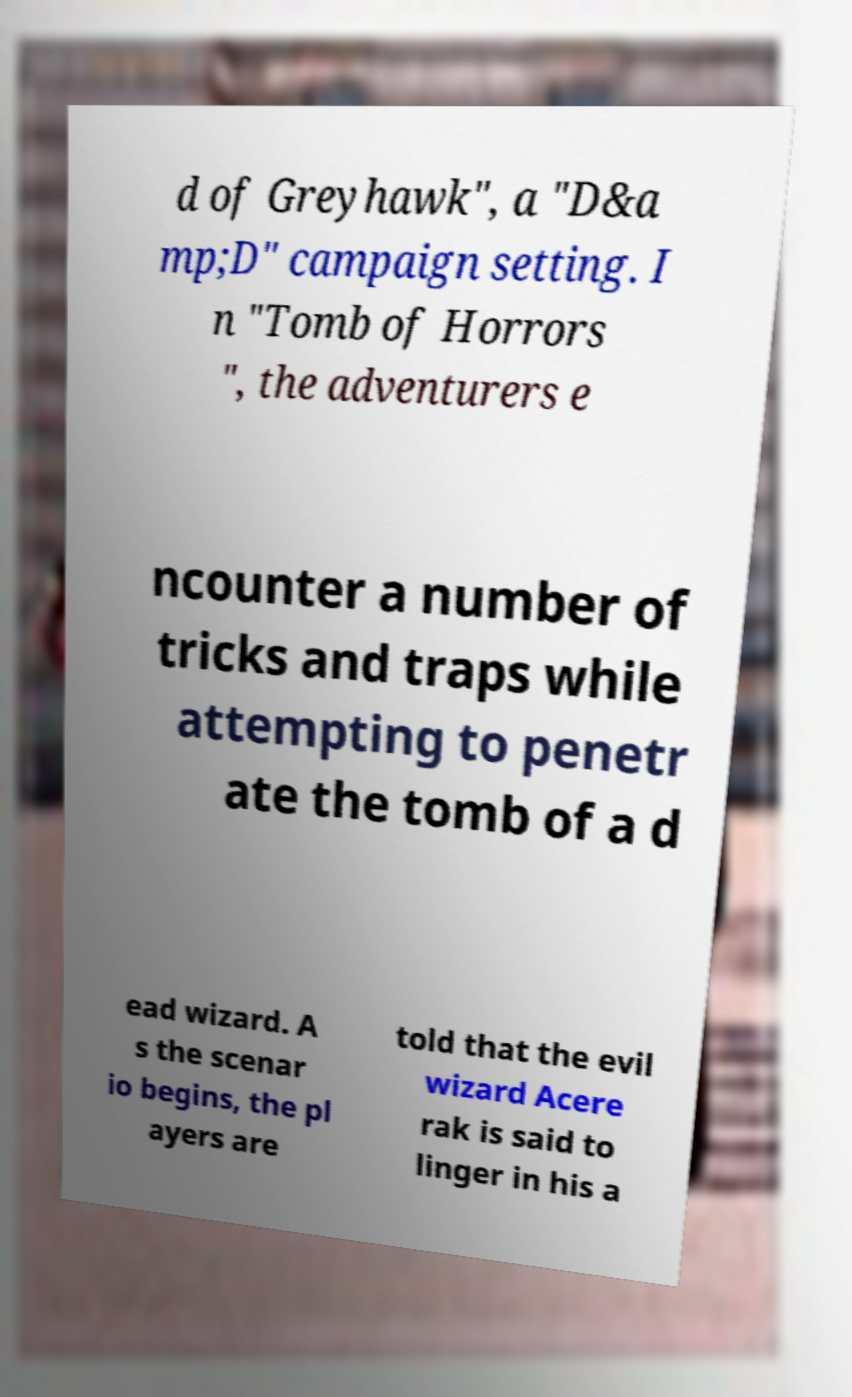There's text embedded in this image that I need extracted. Can you transcribe it verbatim? d of Greyhawk", a "D&a mp;D" campaign setting. I n "Tomb of Horrors ", the adventurers e ncounter a number of tricks and traps while attempting to penetr ate the tomb of a d ead wizard. A s the scenar io begins, the pl ayers are told that the evil wizard Acere rak is said to linger in his a 